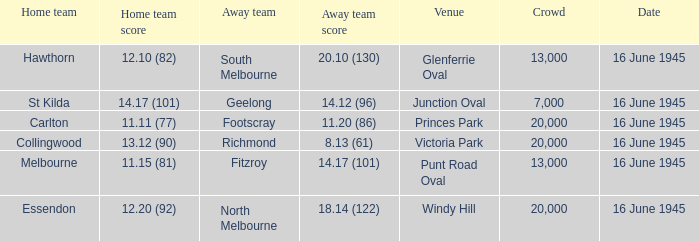What was the Home team score for the team that played South Melbourne? 12.10 (82). 